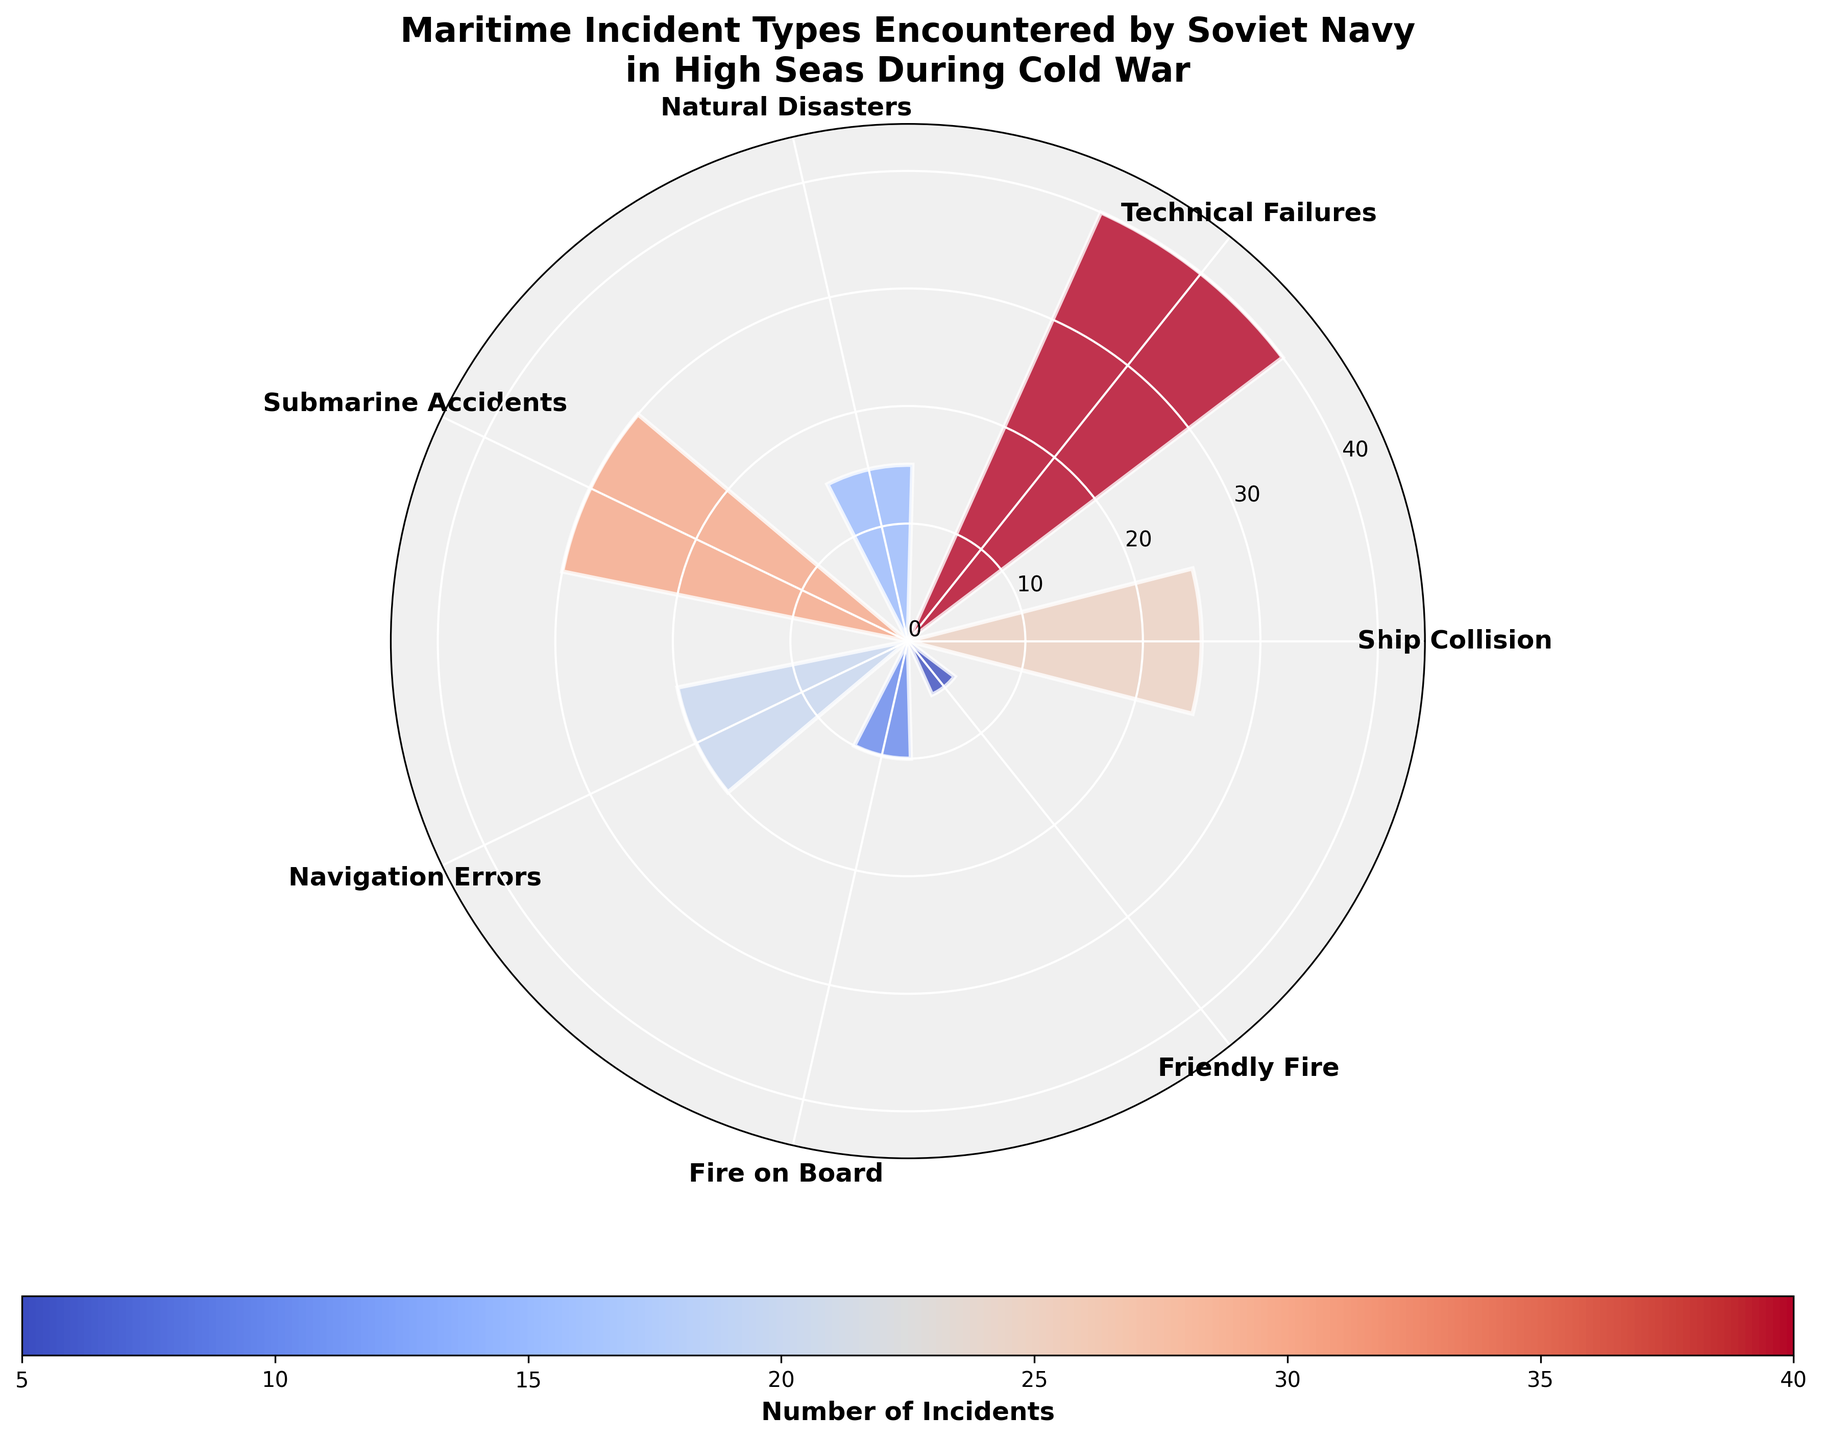What's the title of the chart? The title of the chart is displayed at the top and reads "Maritime Incident Types Encountered by Soviet Navy in High Seas During Cold War".
Answer: Maritime Incident Types Encountered by Soviet Navy in High Seas During Cold War What types of incidents are represented on the chart? The incident types are labeled along the circular axis of the polar area chart. They include Ship Collision, Technical Failures, Natural Disasters, Submarine Accidents, Navigation Errors, Fire on Board, and Friendly Fire.
Answer: Ship Collision, Technical Failures, Natural Disasters, Submarine Accidents, Navigation Errors, Fire on Board, Friendly Fire Which type of incident had the highest number of occurrences? By looking at the heights of the bars, one can see that the tallest bar corresponds to Technical Failures.
Answer: Technical Failures What is the range of the number of incidents? The range can be calculated by subtracting the smallest value from the largest value. The minimum number of incidents is 5 (Friendly Fire) and the maximum is 40 (Technical Failures), so the range is 40 - 5.
Answer: 35 What is the sum of incidents for Ship Collision, Submarine Accidents, and Friendly Fire combined? Adding the number of incidents for these three categories together gives 25 (Ship Collision) + 30 (Submarine Accidents) + 5 (Friendly Fire).
Answer: 60 How does the number of Navigation Errors compare to the number of Fires on Board? Comparing the bar heights for Navigation Errors and Fire on Board shows that Navigation Errors have more incidents than Fires on Board (20 vs. 10).
Answer: Navigation Errors have more incidents Which incidents have fewer than 20 recorded occurrences? By inspecting the bars that do not reach the radial line for 20 incidents, we see that the incidents with fewer than 20 occurrences are Natural Disasters (15), Fire on Board (10), and Friendly Fire (5).
Answer: Natural Disasters, Fire on Board, Friendly Fire What percentage of the total incidents is accounted for by Technical Failures? To find the percentage, we first sum all the incidents (25 + 40 + 15 + 30 + 20 + 10 + 5 = 145) and calculate (40/145) * 100.
Answer: Approximately 27.59% Which incident type is closest in number of occurrences to Ship Collisions? Comparing the numbers visually and numerically, Submarine Accidents have 30 occurrences, which is closest to Ship Collisions' 25 occurrences.
Answer: Submarine Accidents How many incident types have at least 20 recorded incidents? By observing the bars that reach or extend beyond 20 incidents, the incident types are Ship Collision (25), Technical Failures (40), Submarine Accidents (30), and Navigation Errors (20).
Answer: Four 